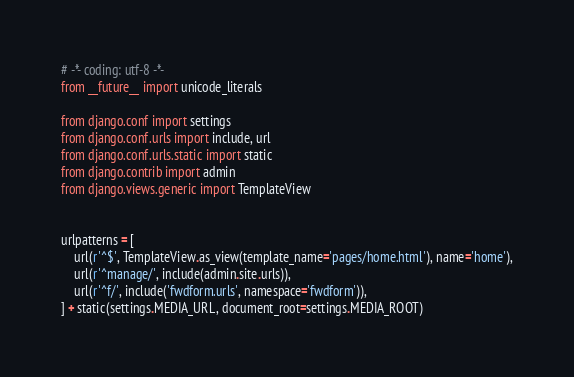<code> <loc_0><loc_0><loc_500><loc_500><_Python_># -*- coding: utf-8 -*-
from __future__ import unicode_literals

from django.conf import settings
from django.conf.urls import include, url
from django.conf.urls.static import static
from django.contrib import admin
from django.views.generic import TemplateView


urlpatterns = [
    url(r'^$', TemplateView.as_view(template_name='pages/home.html'), name='home'),
    url(r'^manage/', include(admin.site.urls)),
    url(r'^f/', include('fwdform.urls', namespace='fwdform')),
] + static(settings.MEDIA_URL, document_root=settings.MEDIA_ROOT)

</code> 